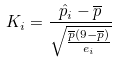Convert formula to latex. <formula><loc_0><loc_0><loc_500><loc_500>K _ { i } = \frac { \hat { p } _ { i } - \overline { p } } { \sqrt { \frac { \overline { p } ( 9 - \overline { p } ) } { e _ { i } } } }</formula> 